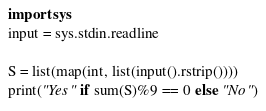<code> <loc_0><loc_0><loc_500><loc_500><_Python_>import sys
input = sys.stdin.readline

S = list(map(int, list(input().rstrip())))
print("Yes" if sum(S)%9 == 0 else "No")
</code> 